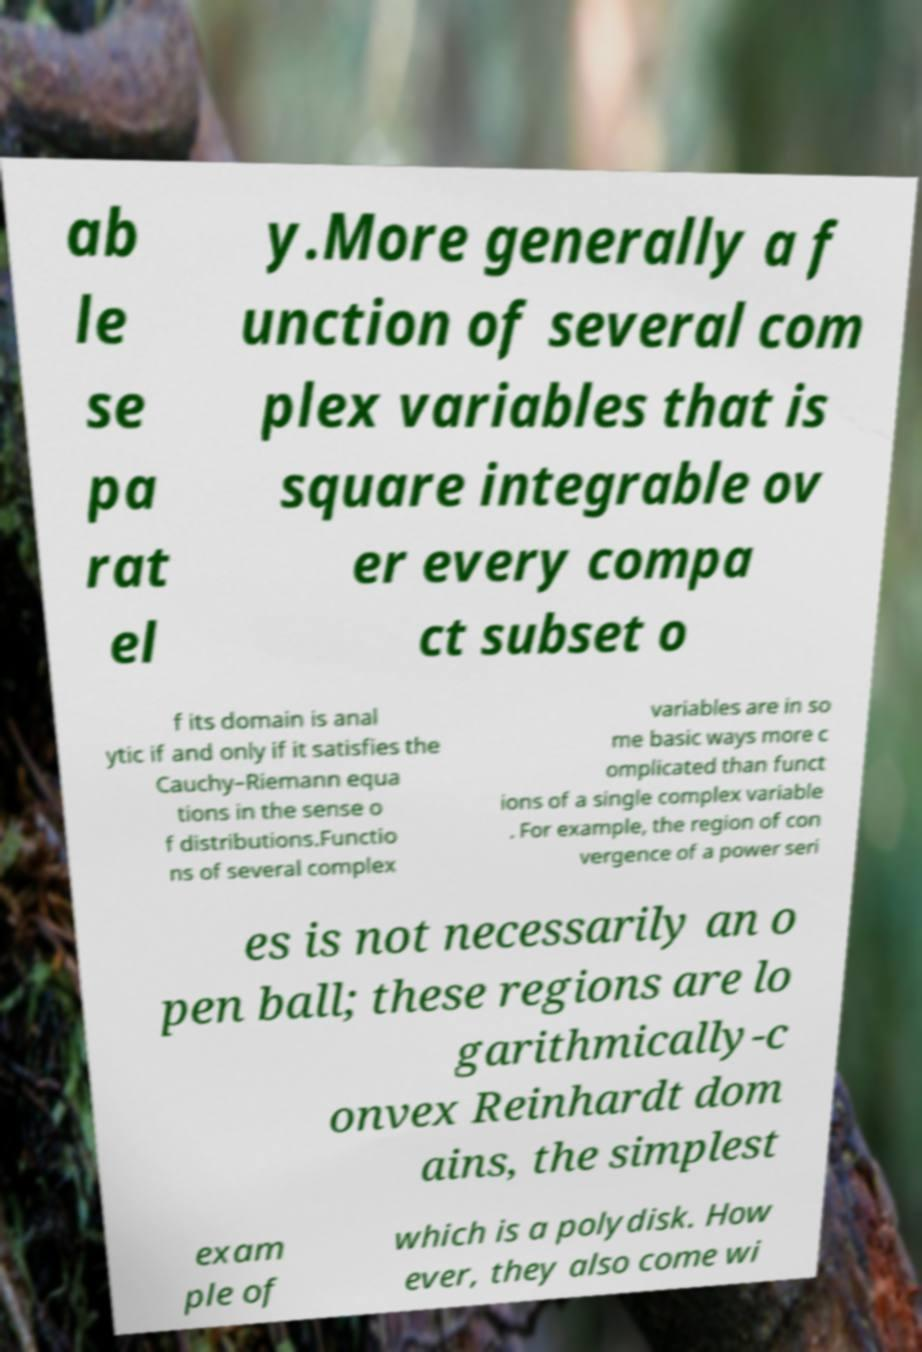Can you accurately transcribe the text from the provided image for me? ab le se pa rat el y.More generally a f unction of several com plex variables that is square integrable ov er every compa ct subset o f its domain is anal ytic if and only if it satisfies the Cauchy–Riemann equa tions in the sense o f distributions.Functio ns of several complex variables are in so me basic ways more c omplicated than funct ions of a single complex variable . For example, the region of con vergence of a power seri es is not necessarily an o pen ball; these regions are lo garithmically-c onvex Reinhardt dom ains, the simplest exam ple of which is a polydisk. How ever, they also come wi 